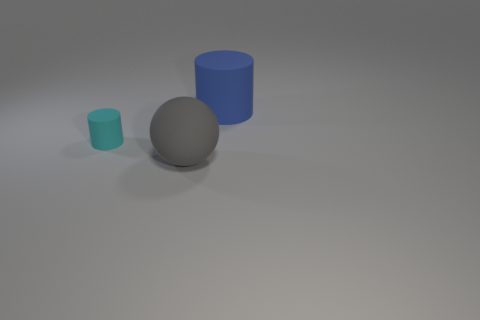Add 3 tiny blue matte cubes. How many objects exist? 6 Subtract all cylinders. How many objects are left? 1 Add 1 purple blocks. How many purple blocks exist? 1 Subtract 0 brown cylinders. How many objects are left? 3 Subtract all blue rubber objects. Subtract all big rubber balls. How many objects are left? 1 Add 3 big gray matte things. How many big gray matte things are left? 4 